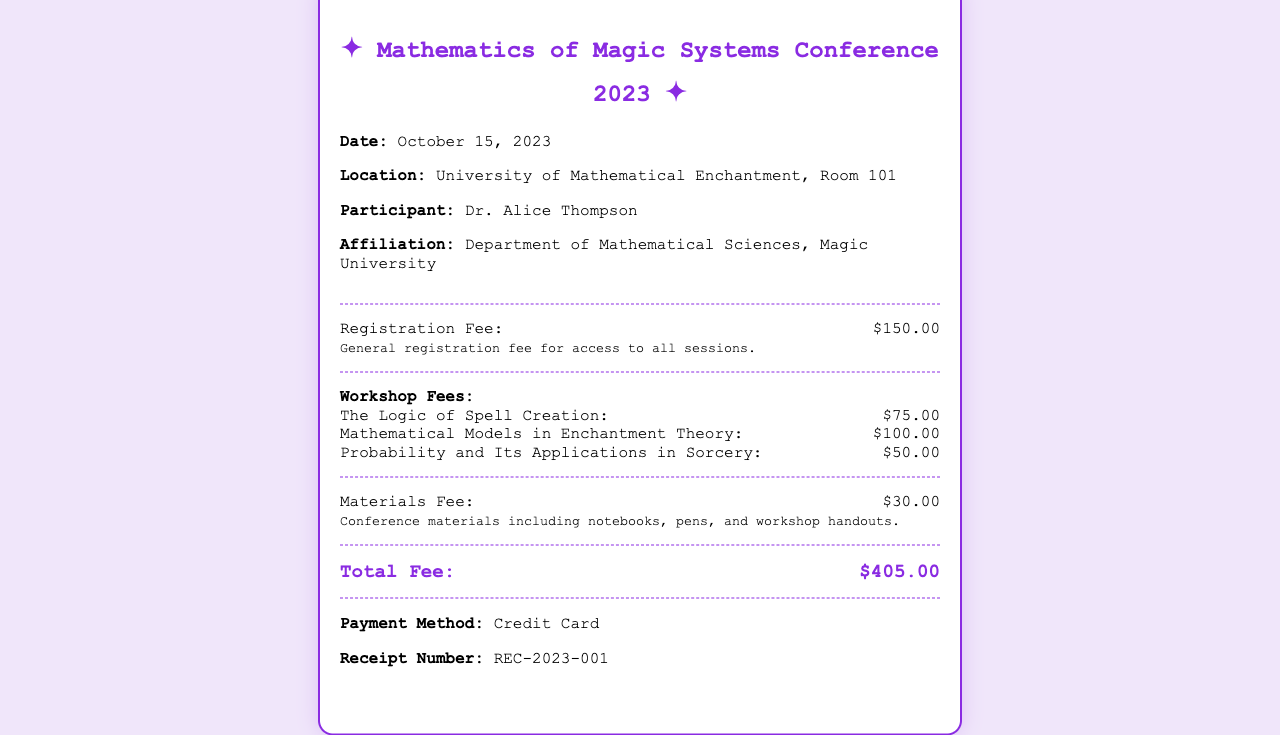What is the date of the conference? The date of the conference can be found in the document, which states it is October 15, 2023.
Answer: October 15, 2023 Who is the participant? The participant's name is listed in the document, which identifies them as Dr. Alice Thompson.
Answer: Dr. Alice Thompson What is the total fee for the conference? The total fee is provided in the document and can be found under the total section, which sums up all fees.
Answer: $405.00 How much is the registration fee? The registration fee is detailed in the document and states that the fee is $150.00.
Answer: $150.00 What workshop has the highest fee? The document lists the workshop fees, and the one with the highest fee is "Mathematical Models in Enchantment Theory" at $100.00.
Answer: Mathematical Models in Enchantment Theory What is included in the materials fee? The document mentions that the materials fee covers notebooks, pens, and workshop handouts.
Answer: Notebooks, pens, and workshop handouts What is the payment method used? The document states that the payment method for the conference fee was a credit card.
Answer: Credit Card What is the receipt number? The receipt number can be found at the end of the document, which identifies it as REC-2023-001.
Answer: REC-2023-001 Which workshop focuses on probability? The document identifies the workshop that focuses on probability as "Probability and Its Applications in Sorcery."
Answer: Probability and Its Applications in Sorcery 